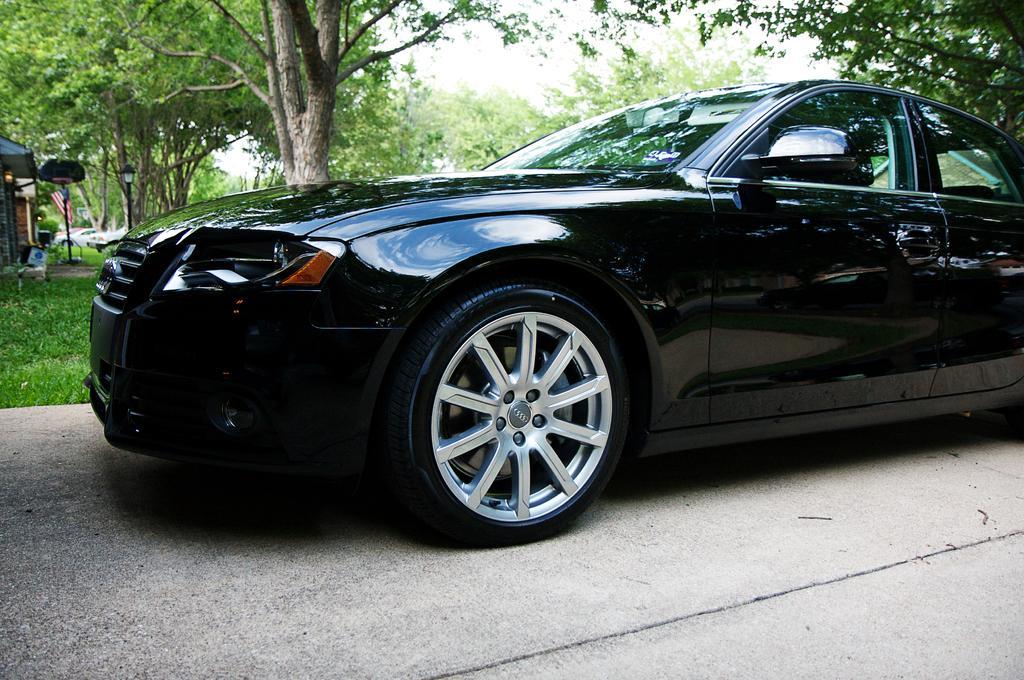Please provide a concise description of this image. In this image we can see a car parked on the road. On the backside we can see a group of trees, grass, a pole and the sky. 